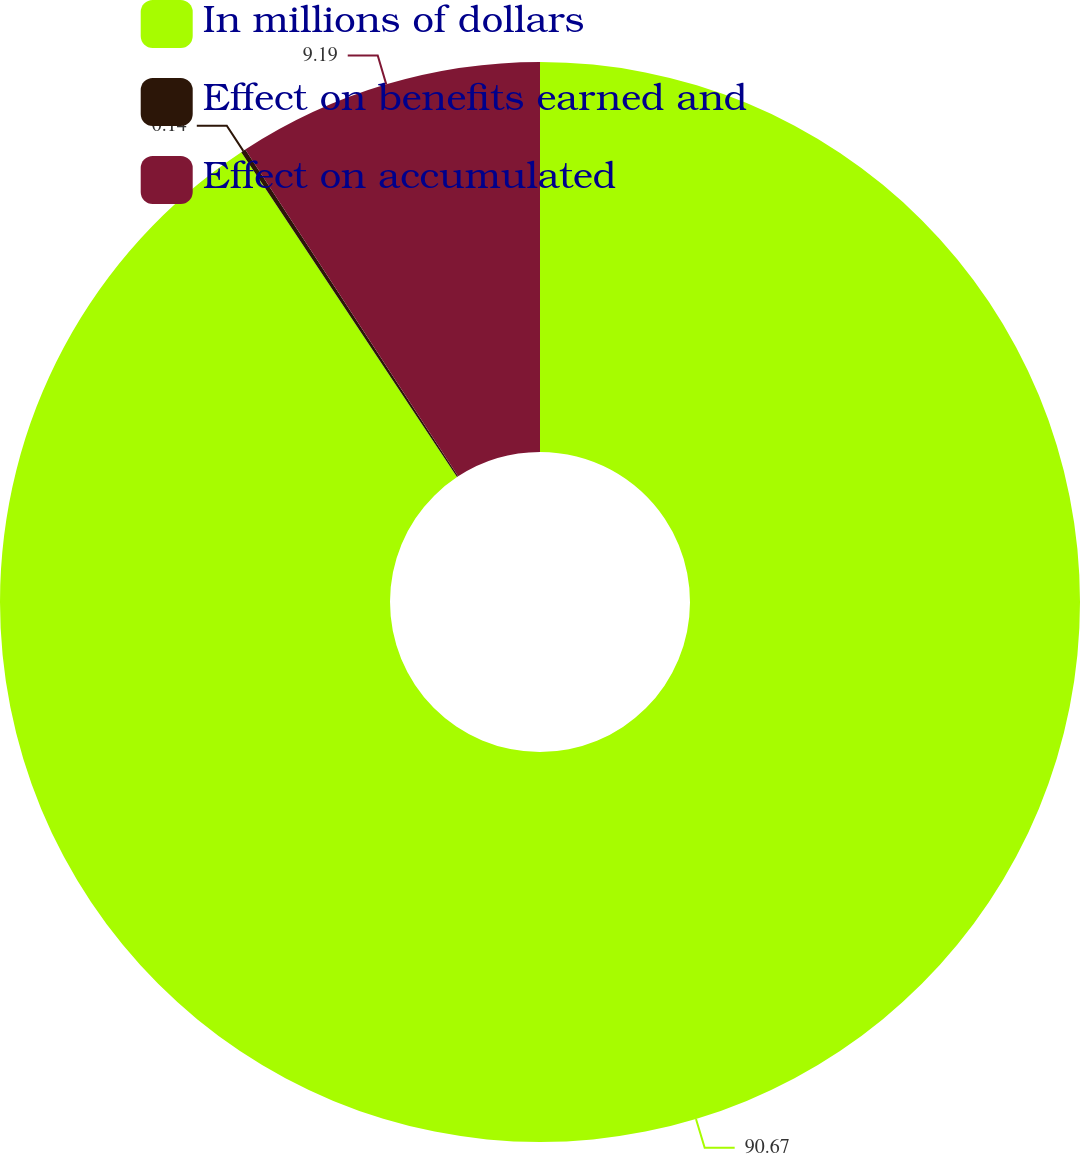Convert chart. <chart><loc_0><loc_0><loc_500><loc_500><pie_chart><fcel>In millions of dollars<fcel>Effect on benefits earned and<fcel>Effect on accumulated<nl><fcel>90.68%<fcel>0.14%<fcel>9.19%<nl></chart> 